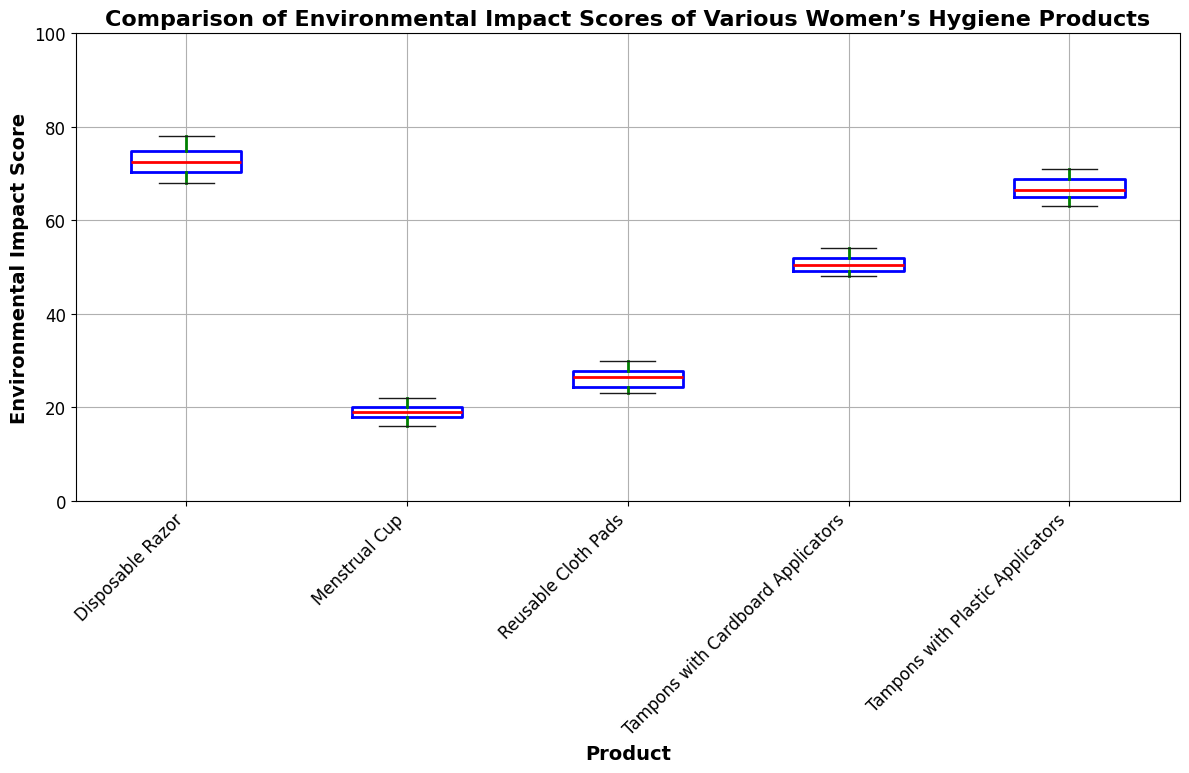What product has the highest median Environmental Impact Score? To determine the highest median score, look for the feature indicating the median on each box plot, typically a red line. Compare these medians across all products.
Answer: Disposable Razor Which product shows the most variability in Environmental Impact Scores? To find the product with the most variability, look at the length of the boxes and whiskers. The product with the longest box and whiskers has the most variability.
Answer: Disposable Razor Are tampons with plastic applicators or tampons with cardboard applicators more environmentally friendly based on their median scores? Compare the median lines (red lines) for both products. The lower the median, the more environmentally friendly the product is.
Answer: Tampons with Cardboard Applicators Which two products have the closest median scores? Visually compare the position of the median lines (red lines) across all products and find the two closest lines.
Answer: Reusable Cloth Pads and Tampons with Cardboard Applicators What is the range of Environmental Impact Scores for the Menstrual Cup? To find the range, identify the minimum and maximum values within the whiskers of the Menstrual Cup box plot, then calculate the difference.
Answer: 16 to 22 Which product, between Disposable Razor and Reusable Cloth Pads, has a lower maximum score? Compare the top whisker endpoints of both box plots to see which one is lower.
Answer: Reusable Cloth Pads What can be inferred about the mean scores if you have only the median and range information for each product? The mean might not be directly identified but can be inferred reasonably well from the median and variability. Products with lower median and tighter ranges likely have lower means. In contrast, those with higher medians and broader ranges likely have higher means.
Answer: Inference By how much does the median Environmental Impact Score of Disposable Razor exceed that of the Menstrual Cup? Subtract the median score of the Menstrual Cup from the median score of the Disposable Razor by identifying the two median lines.
Answer: Approximately 54 Which visual cue should you look at to determine the consistency of a product's Environmental Impact Scores? To determine consistency, examine the length of the boxes and whiskers. Shorter boxes and whiskers indicate higher consistency.
Answer: Box and Whiskers For a person with eco-conscious values, which product should be preferred based on the box plot data? Based on the box plot, look for the product with the lowest overall scores (lower median and shorter range), indicating the least environmental impact.
Answer: Menstrual Cup 